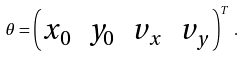<formula> <loc_0><loc_0><loc_500><loc_500>\theta = \begin{pmatrix} x _ { 0 } & y _ { 0 } & v _ { x } & v _ { y } \end{pmatrix} ^ { T } \, .</formula> 